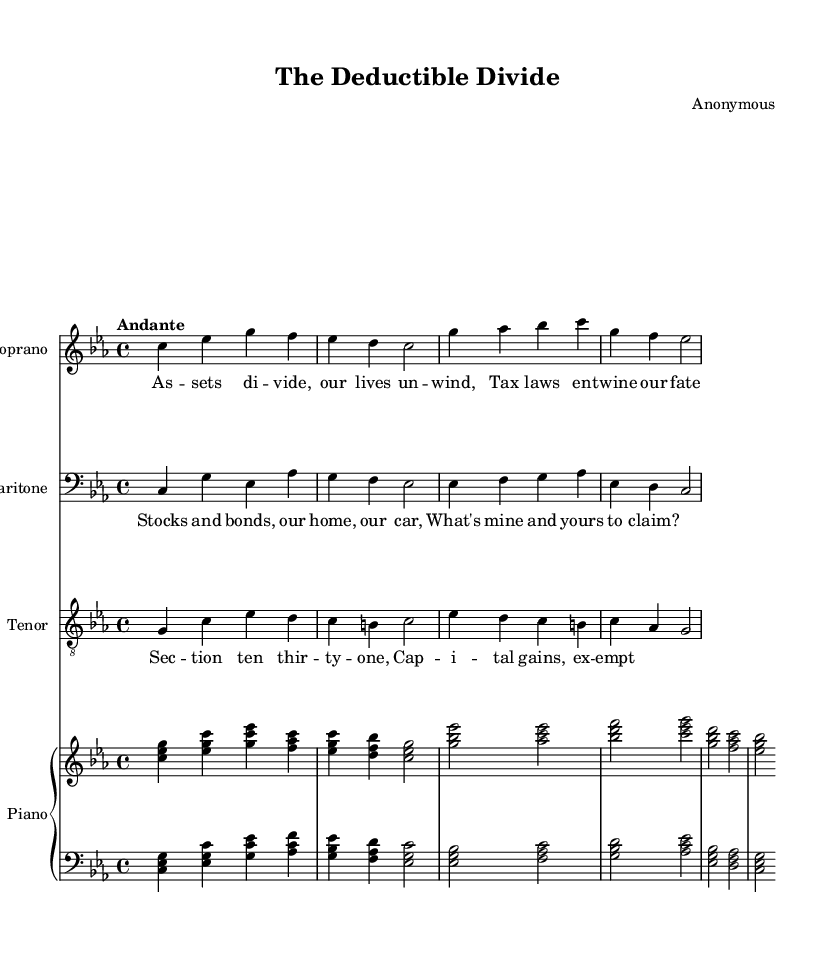What is the key signature of this music? The key signature is indicated at the beginning of the staff and shows C minor, which has three flats (B flat, E flat, and A flat).
Answer: C minor What is the time signature of this music? The time signature is displayed as a fraction at the beginning of the staff, showing 4 over 4, meaning there are four beats in each measure.
Answer: 4/4 What is the tempo marking of this piece? The tempo marking appears at the beginning, stating "Andante," which indicates a moderate walking pace.
Answer: Andante How many voices are present in this opera? The score includes three distinct voices: Soprano, Baritone, and Tenor, each having their respective staves.
Answer: Three Which character sings about “Stocks and bonds”? The lyrics associated with the Baritone voice mention “Stocks and bonds, our home, our car, What's mine and yours to claim?” indicating this character's concerns regarding financial division.
Answer: Baritone What is the dynamic marking for the soprano in the first measure? In the first measure, the dynamic marking for the Soprano is indicated as "mp" (mezzo-piano), suggesting a moderately soft sound.
Answer: mp What is the thematic focus of the lyrics in this opera? The lyrics depict complex financial situations in a divorce, focusing on issues such as asset division, tax implications, and emotional struggles, emphasized by phrases like "Tax laws entwine our fate."
Answer: Financial division 